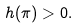<formula> <loc_0><loc_0><loc_500><loc_500>h ( \pi ) > 0 .</formula> 